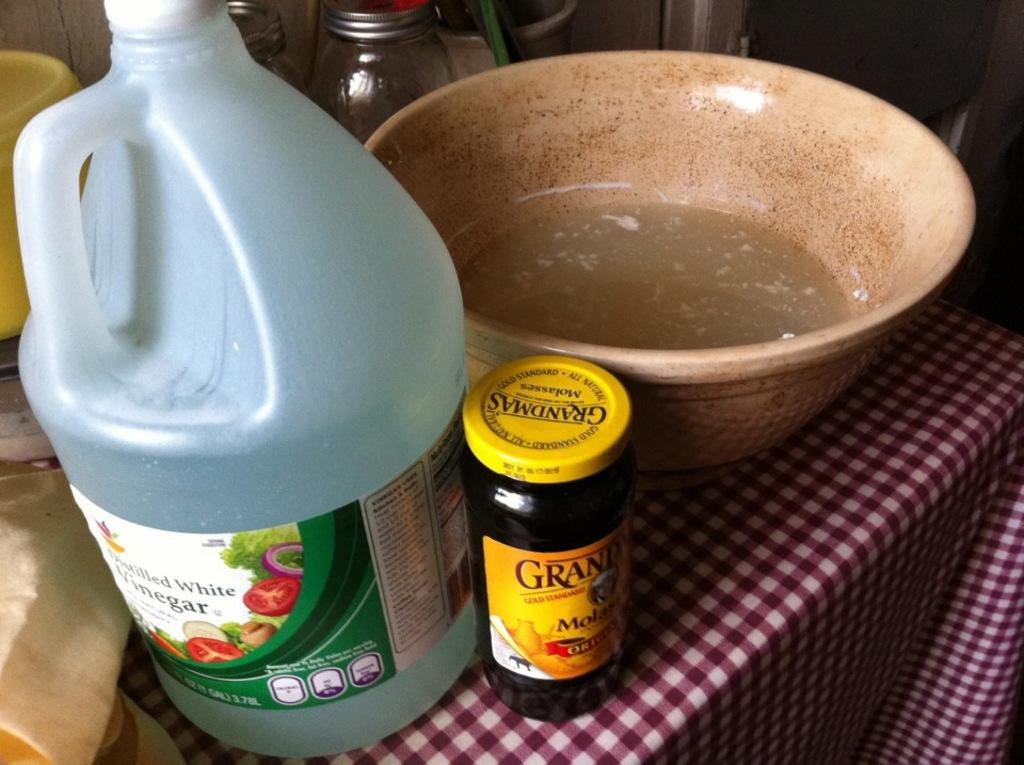What color is the can in the image? The can in the image is blue. What other objects can be seen on the table in the image? There is a bottle, a bowl, and jars visible on the table in the image. How many buttons are on the wren in the image? There is no wren or buttons present in the image. What type of blow can be seen in the image? There is no blow or any related action depicted in the image. 